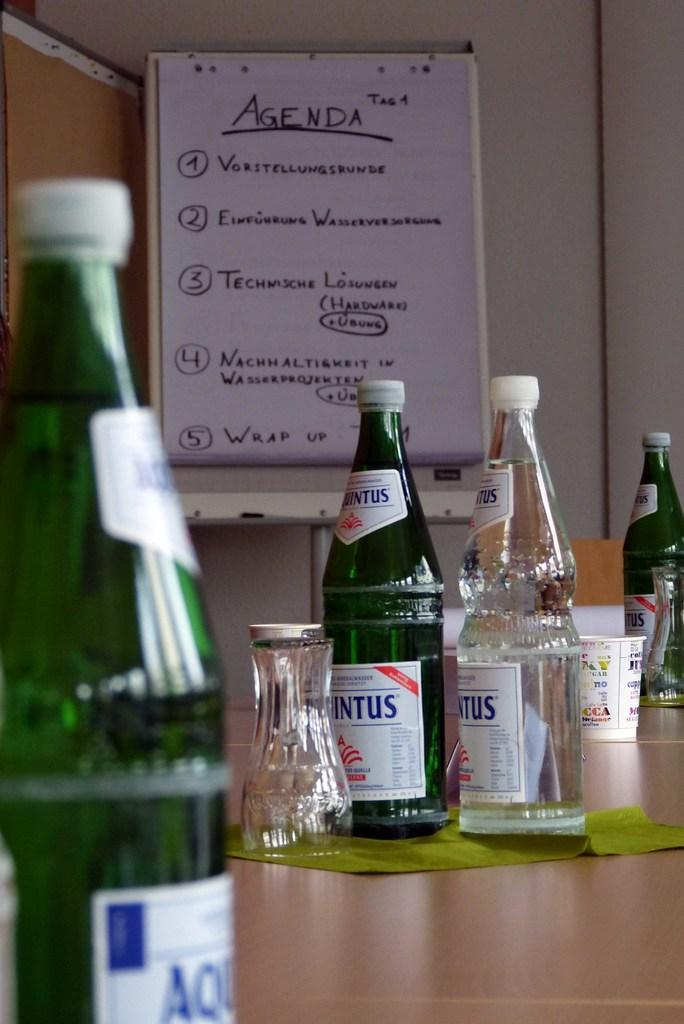Provide a one-sentence caption for the provided image. Various glass bottles are spread across the counter over tops of it an agenda is clipped up. 